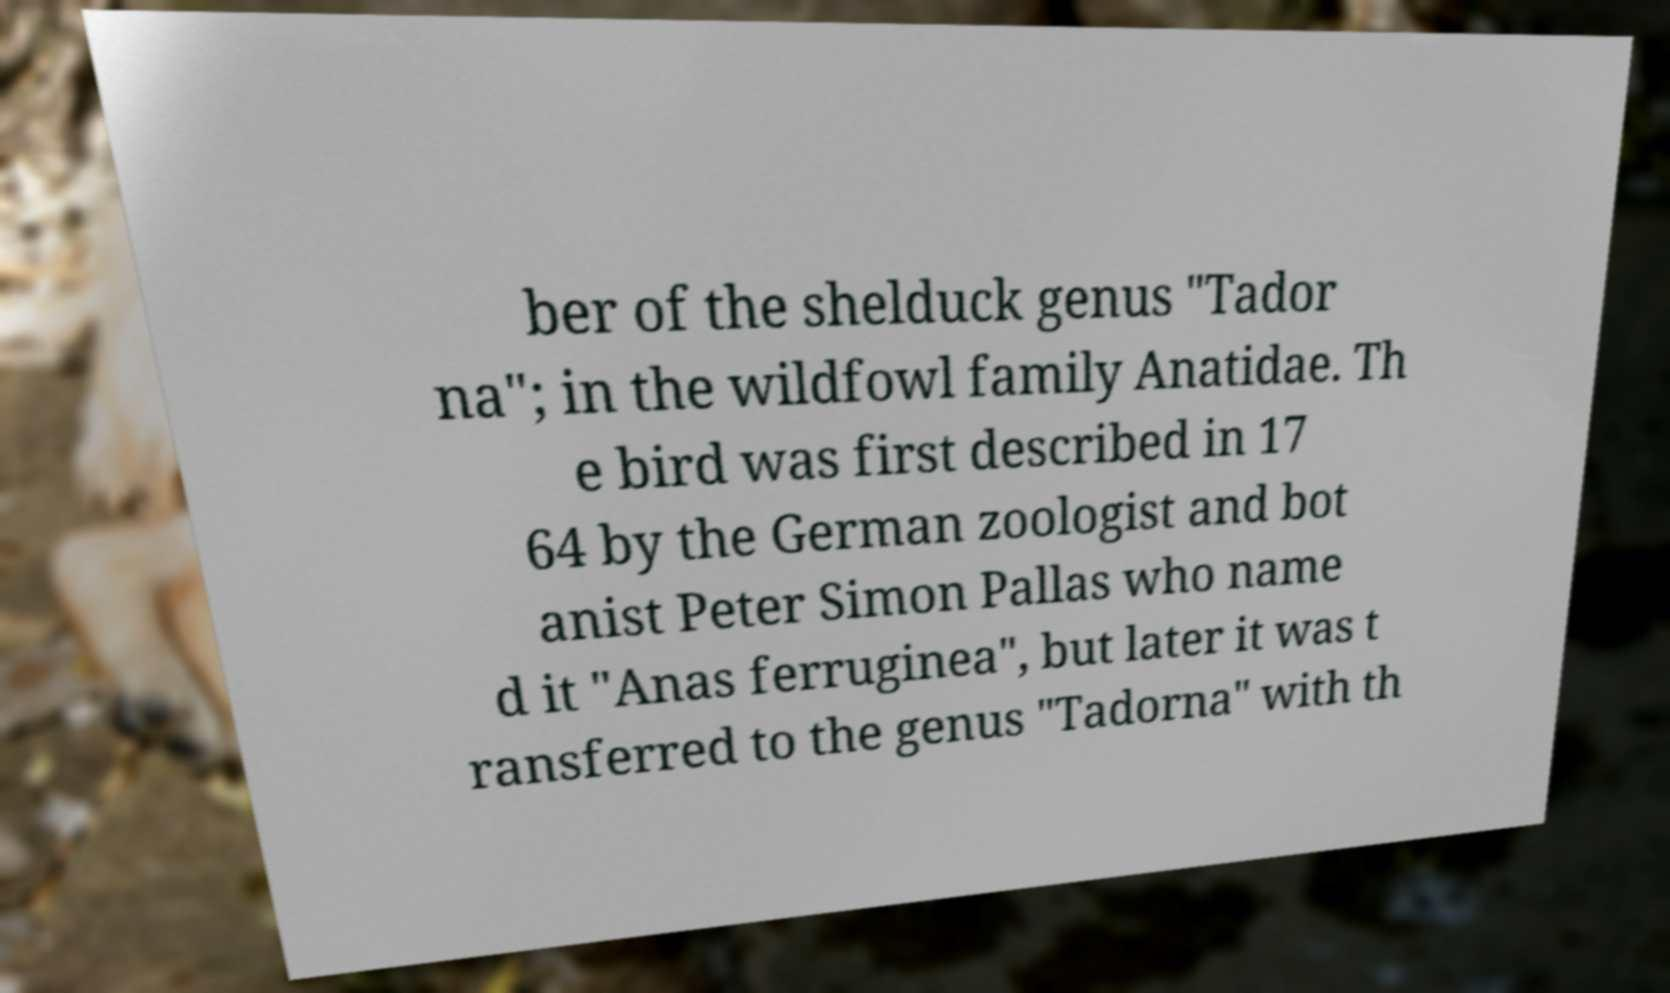I need the written content from this picture converted into text. Can you do that? ber of the shelduck genus "Tador na"; in the wildfowl family Anatidae. Th e bird was first described in 17 64 by the German zoologist and bot anist Peter Simon Pallas who name d it "Anas ferruginea", but later it was t ransferred to the genus "Tadorna" with th 